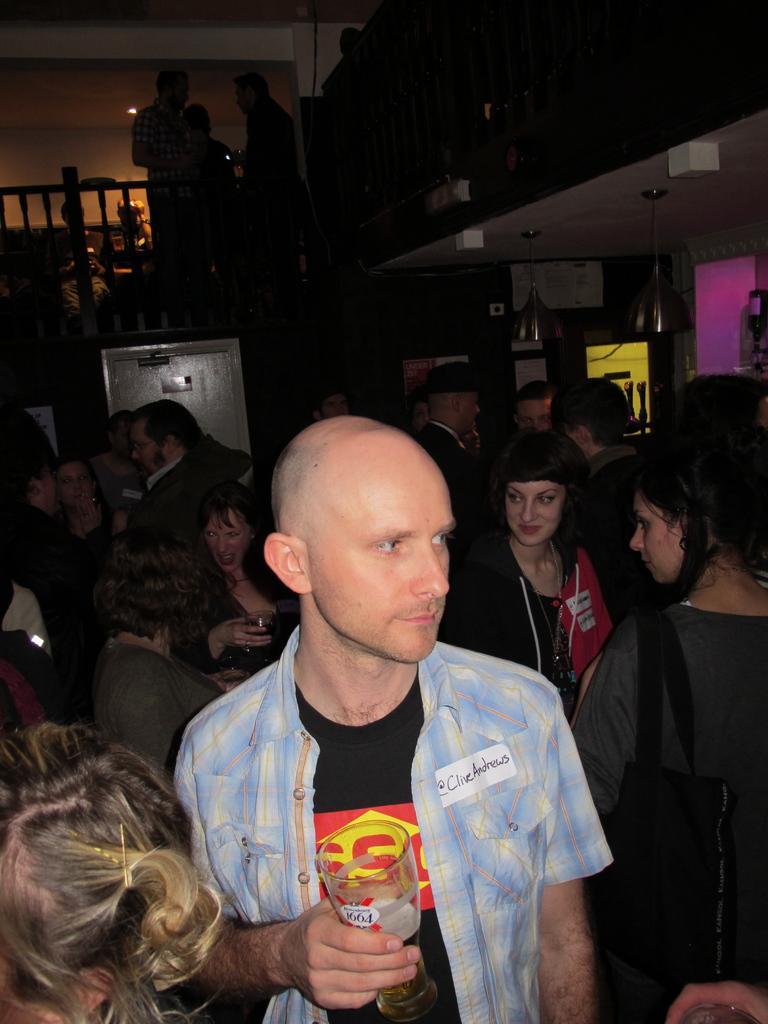How would you summarize this image in a sentence or two? The image is taken in a bar. In the foreground of the picture there is a person holding a drink, behind him there are people. At the top there are people standing by the railing. In the center of the picture there are bottles and other objects. 